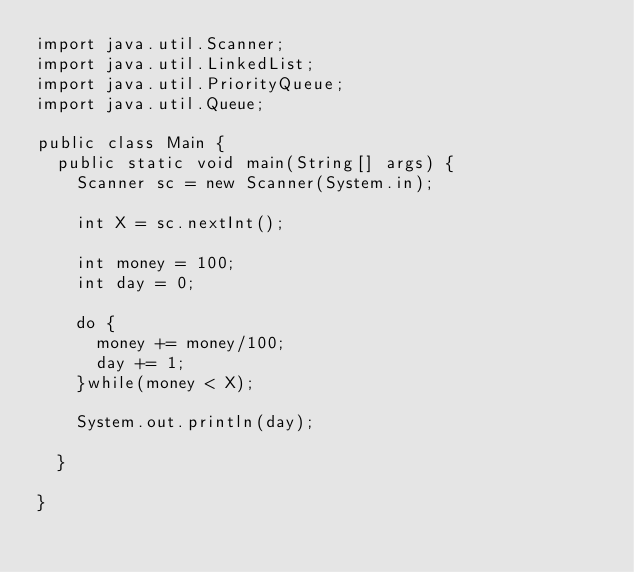Convert code to text. <code><loc_0><loc_0><loc_500><loc_500><_Java_>import java.util.Scanner;
import java.util.LinkedList;
import java.util.PriorityQueue;
import java.util.Queue;

public class Main {	
	public static void main(String[] args) {
		Scanner sc = new Scanner(System.in);
		
		int X = sc.nextInt();

		int money = 100;
		int day = 0;
		
		do {
			money += money/100;
			day += 1;
		}while(money < X);
		
		System.out.println(day);
		
	}

}</code> 